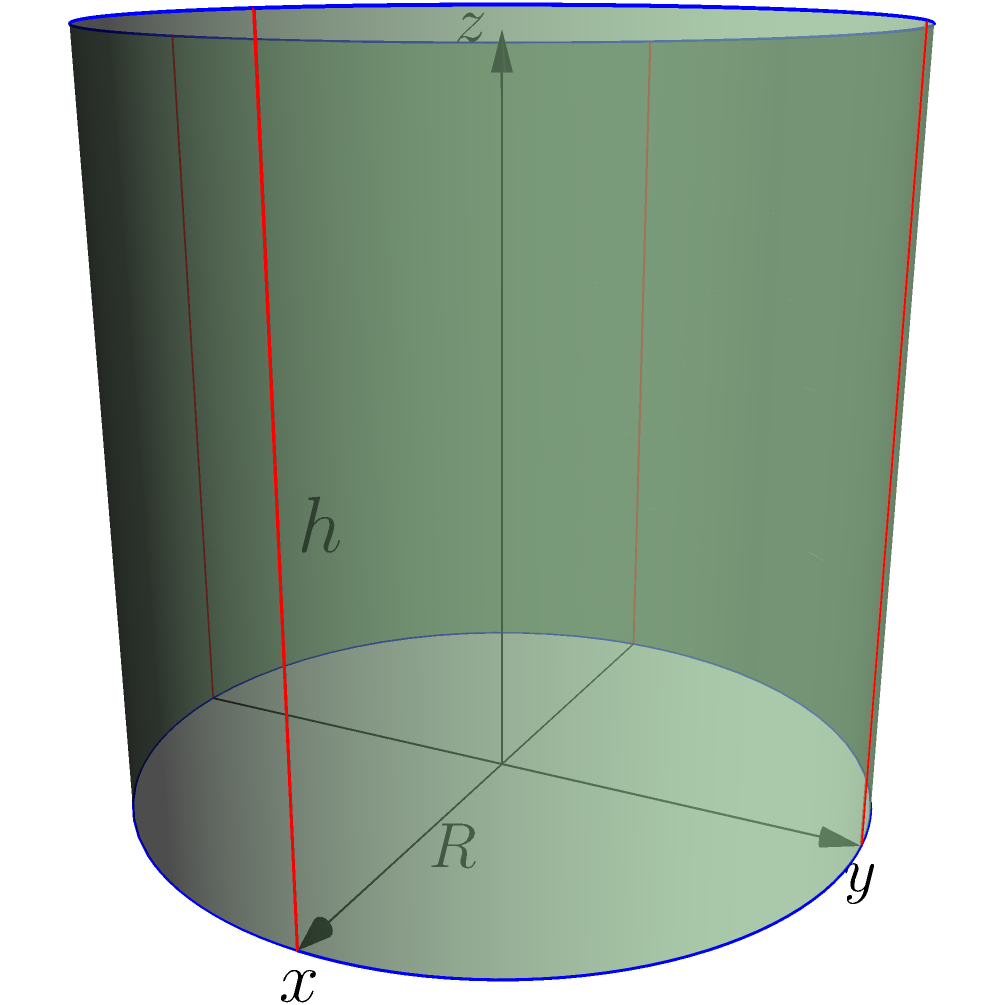As a biomedical engineer, you're designing a cylindrical medical implant. The implant has a radius of 2 cm and a height of 3 cm. Using cylindrical coordinates, calculate the volume of the implant. Round your answer to two decimal places. To calculate the volume of the cylindrical implant using cylindrical coordinates, we'll follow these steps:

1) The volume formula in cylindrical coordinates is:

   $$V = \int_0^{2\pi} \int_0^R \int_0^h r \, dz \, dr \, d\theta$$

   Where $R$ is the radius, $h$ is the height, $r$ is the radial coordinate, $\theta$ is the angular coordinate, and $z$ is the height coordinate.

2) Given:
   $R = 2$ cm
   $h = 3$ cm

3) Let's solve the triple integral:

   $$V = \int_0^{2\pi} \int_0^2 \int_0^3 r \, dz \, dr \, d\theta$$

4) First, integrate with respect to $z$:

   $$V = \int_0^{2\pi} \int_0^2 [rz]_0^3 \, dr \, d\theta = \int_0^{2\pi} \int_0^2 3r \, dr \, d\theta$$

5) Now, integrate with respect to $r$:

   $$V = \int_0^{2\pi} [\frac{3r^2}{2}]_0^2 \, d\theta = \int_0^{2\pi} 6 \, d\theta$$

6) Finally, integrate with respect to $\theta$:

   $$V = [6\theta]_0^{2\pi} = 12\pi$$

7) Convert to cm³:

   $$V = 12\pi \approx 37.70 \text{ cm}^3$$

Therefore, the volume of the cylindrical implant is approximately 37.70 cm³.
Answer: 37.70 cm³ 